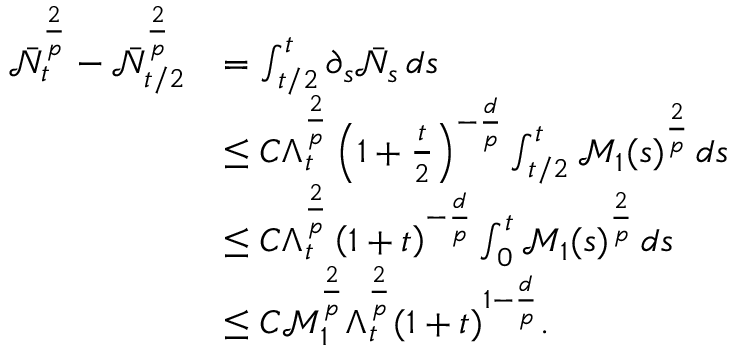<formula> <loc_0><loc_0><loc_500><loc_500>\begin{array} { r l } { \bar { \mathcal { N } } _ { t } ^ { \frac { 2 } { p } } - \bar { \mathcal { N } } _ { t / 2 } ^ { \frac { 2 } { p } } } & { = \int _ { t / 2 } ^ { t } \partial _ { s } \bar { \mathcal { N } } _ { s } \, d s } \\ & { \leq C \Lambda _ { t } ^ { \frac { 2 } { p } } \left ( 1 + \frac { t } { 2 } \right ) ^ { - \frac { d } { p } } \int _ { t / 2 } ^ { t } \mathcal { M } _ { 1 } ( s ) ^ { \frac { 2 } { p } } \, d s } \\ & { \leq C \Lambda _ { t } ^ { \frac { 2 } { p } } \left ( 1 + t \right ) ^ { - \frac { d } { p } } \int _ { 0 } ^ { t } \mathcal { M } _ { 1 } ( s ) ^ { \frac { 2 } { p } } \, d s } \\ & { \leq C \ m a t h s c r { M } _ { 1 } ^ { \frac { 2 } { p } } \Lambda _ { t } ^ { \frac { 2 } { p } } ( 1 + t ) ^ { 1 - \frac { d } { p } } . } \end{array}</formula> 